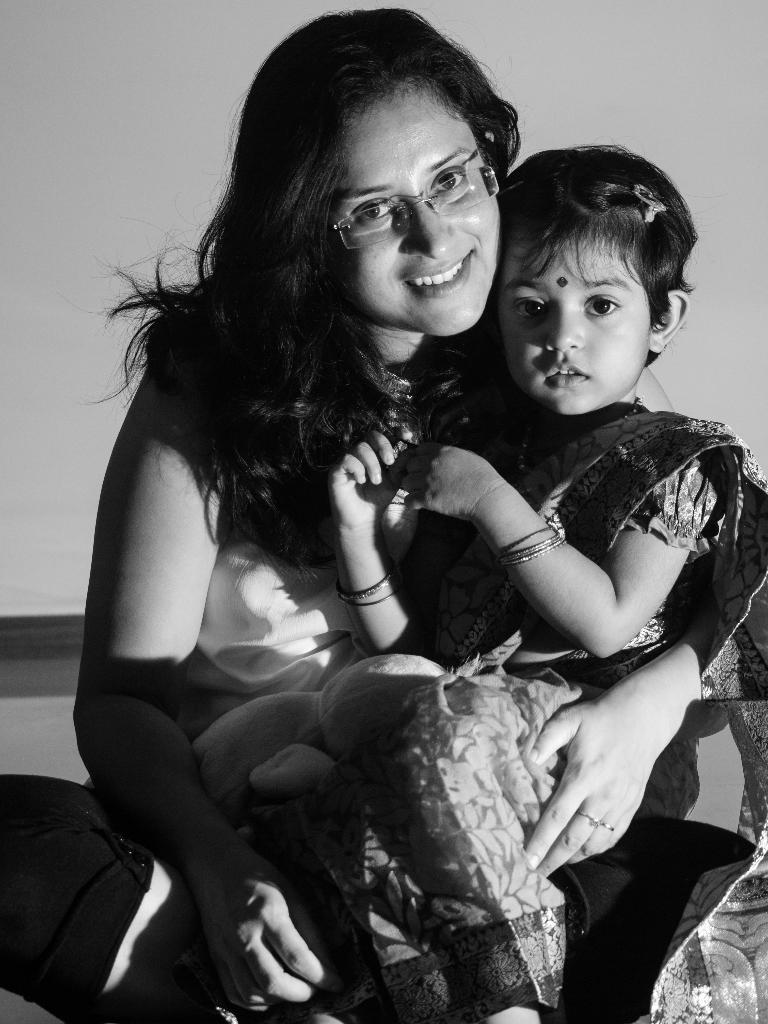Who is present in the image? There is a woman and a girl in the image. What is the woman doing in the image? The woman is sitting on the ground. What is the girl doing in the image? The girl is sitting on the woman's lap. What is the color scheme of the image? The image is in black and white color. What type of bells can be heard ringing in the image? There are no bells present in the image, and therefore no sound can be heard. 